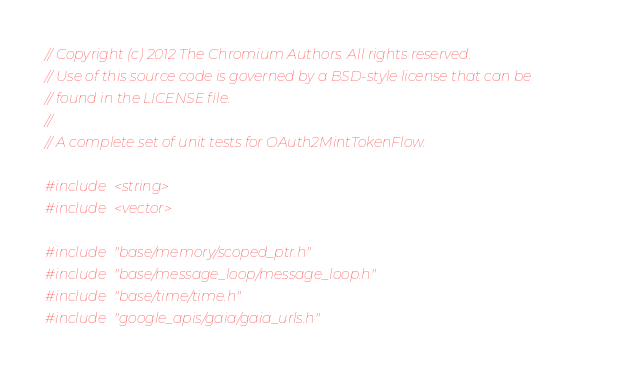Convert code to text. <code><loc_0><loc_0><loc_500><loc_500><_C++_>// Copyright (c) 2012 The Chromium Authors. All rights reserved.
// Use of this source code is governed by a BSD-style license that can be
// found in the LICENSE file.
//
// A complete set of unit tests for OAuth2MintTokenFlow.

#include <string>
#include <vector>

#include "base/memory/scoped_ptr.h"
#include "base/message_loop/message_loop.h"
#include "base/time/time.h"
#include "google_apis/gaia/gaia_urls.h"</code> 